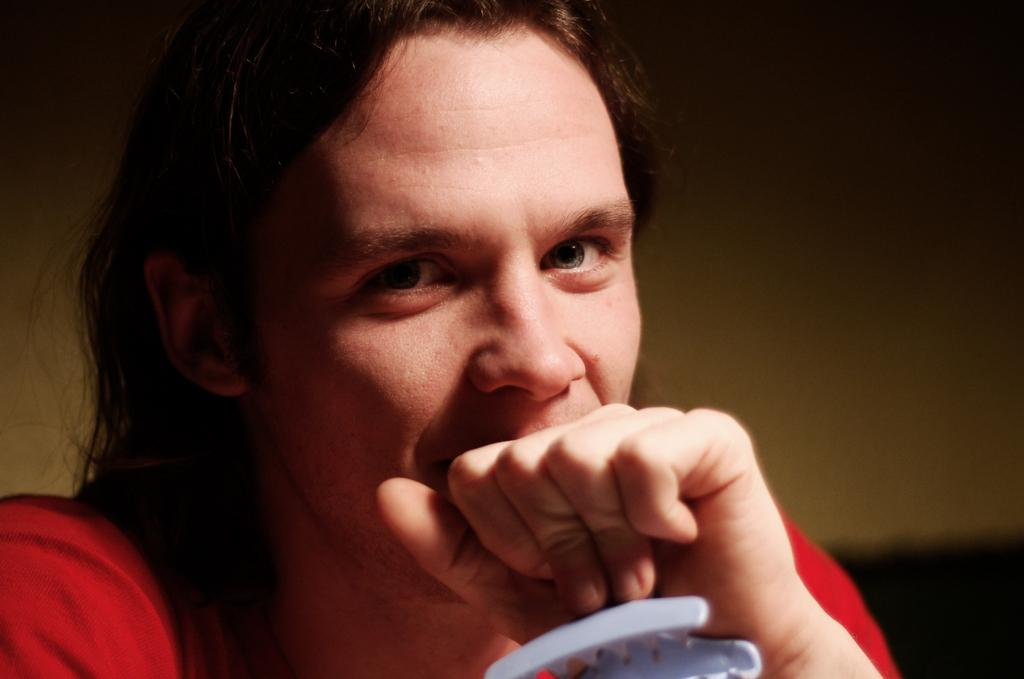What is present in the image? There is a person in the image. What is the person holding? The person is holding something. What can be seen in the background of the image? There is a wall in the background of the image. What type of plantation can be seen in the image? There is no plantation present in the image. How many boats are visible in the image? There are no boats visible in the image. 